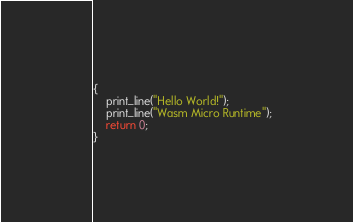Convert code to text. <code><loc_0><loc_0><loc_500><loc_500><_C_>{
    print_line("Hello World!");
    print_line("Wasm Micro Runtime");
    return 0;
}</code> 